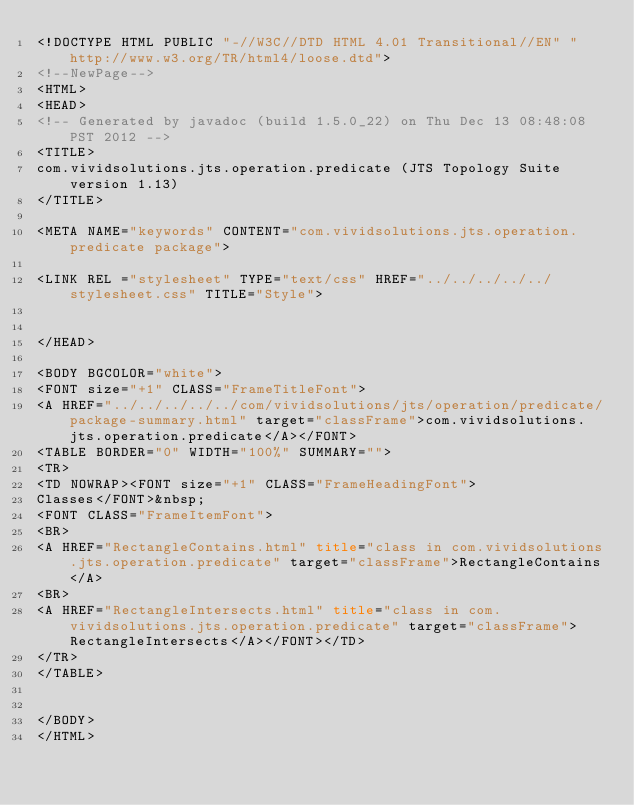Convert code to text. <code><loc_0><loc_0><loc_500><loc_500><_HTML_><!DOCTYPE HTML PUBLIC "-//W3C//DTD HTML 4.01 Transitional//EN" "http://www.w3.org/TR/html4/loose.dtd">
<!--NewPage-->
<HTML>
<HEAD>
<!-- Generated by javadoc (build 1.5.0_22) on Thu Dec 13 08:48:08 PST 2012 -->
<TITLE>
com.vividsolutions.jts.operation.predicate (JTS Topology Suite version 1.13)
</TITLE>

<META NAME="keywords" CONTENT="com.vividsolutions.jts.operation.predicate package">

<LINK REL ="stylesheet" TYPE="text/css" HREF="../../../../../stylesheet.css" TITLE="Style">


</HEAD>

<BODY BGCOLOR="white">
<FONT size="+1" CLASS="FrameTitleFont">
<A HREF="../../../../../com/vividsolutions/jts/operation/predicate/package-summary.html" target="classFrame">com.vividsolutions.jts.operation.predicate</A></FONT>
<TABLE BORDER="0" WIDTH="100%" SUMMARY="">
<TR>
<TD NOWRAP><FONT size="+1" CLASS="FrameHeadingFont">
Classes</FONT>&nbsp;
<FONT CLASS="FrameItemFont">
<BR>
<A HREF="RectangleContains.html" title="class in com.vividsolutions.jts.operation.predicate" target="classFrame">RectangleContains</A>
<BR>
<A HREF="RectangleIntersects.html" title="class in com.vividsolutions.jts.operation.predicate" target="classFrame">RectangleIntersects</A></FONT></TD>
</TR>
</TABLE>


</BODY>
</HTML>
</code> 